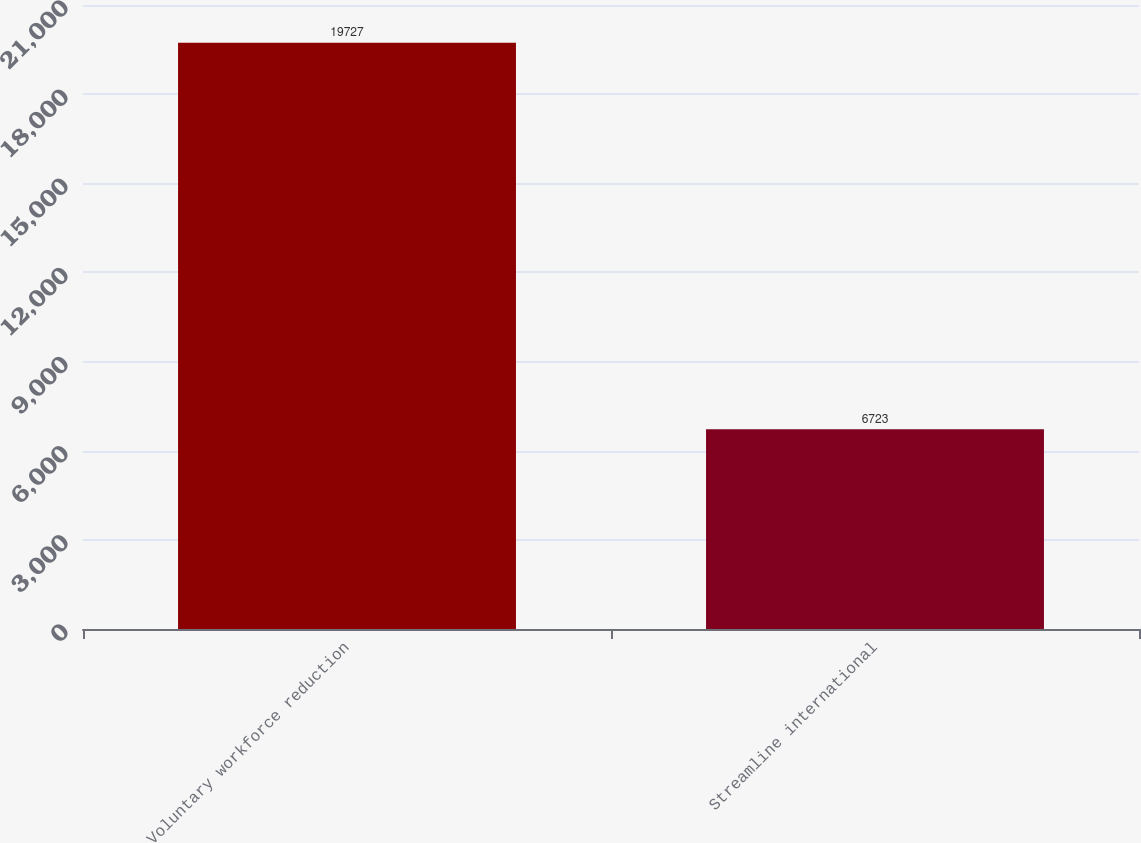Convert chart to OTSL. <chart><loc_0><loc_0><loc_500><loc_500><bar_chart><fcel>Voluntary workforce reduction<fcel>Streamline international<nl><fcel>19727<fcel>6723<nl></chart> 